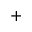<formula> <loc_0><loc_0><loc_500><loc_500>+</formula> 